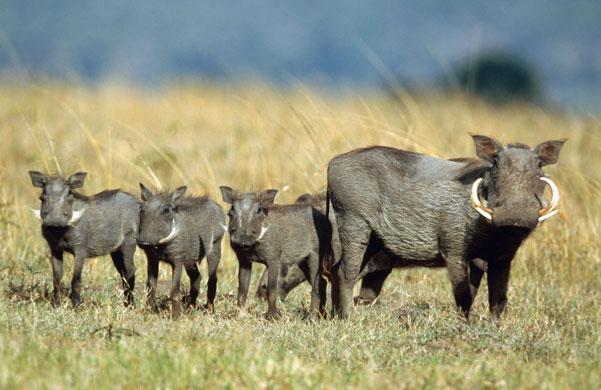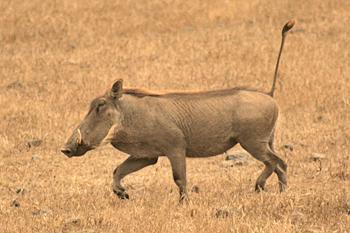The first image is the image on the left, the second image is the image on the right. Assess this claim about the two images: "There's exactly two warthogs in the left image.". Correct or not? Answer yes or no. No. The first image is the image on the left, the second image is the image on the right. Evaluate the accuracy of this statement regarding the images: "An image with a row of at least three warthogs includes at least one that looks straight at the camera.". Is it true? Answer yes or no. Yes. 